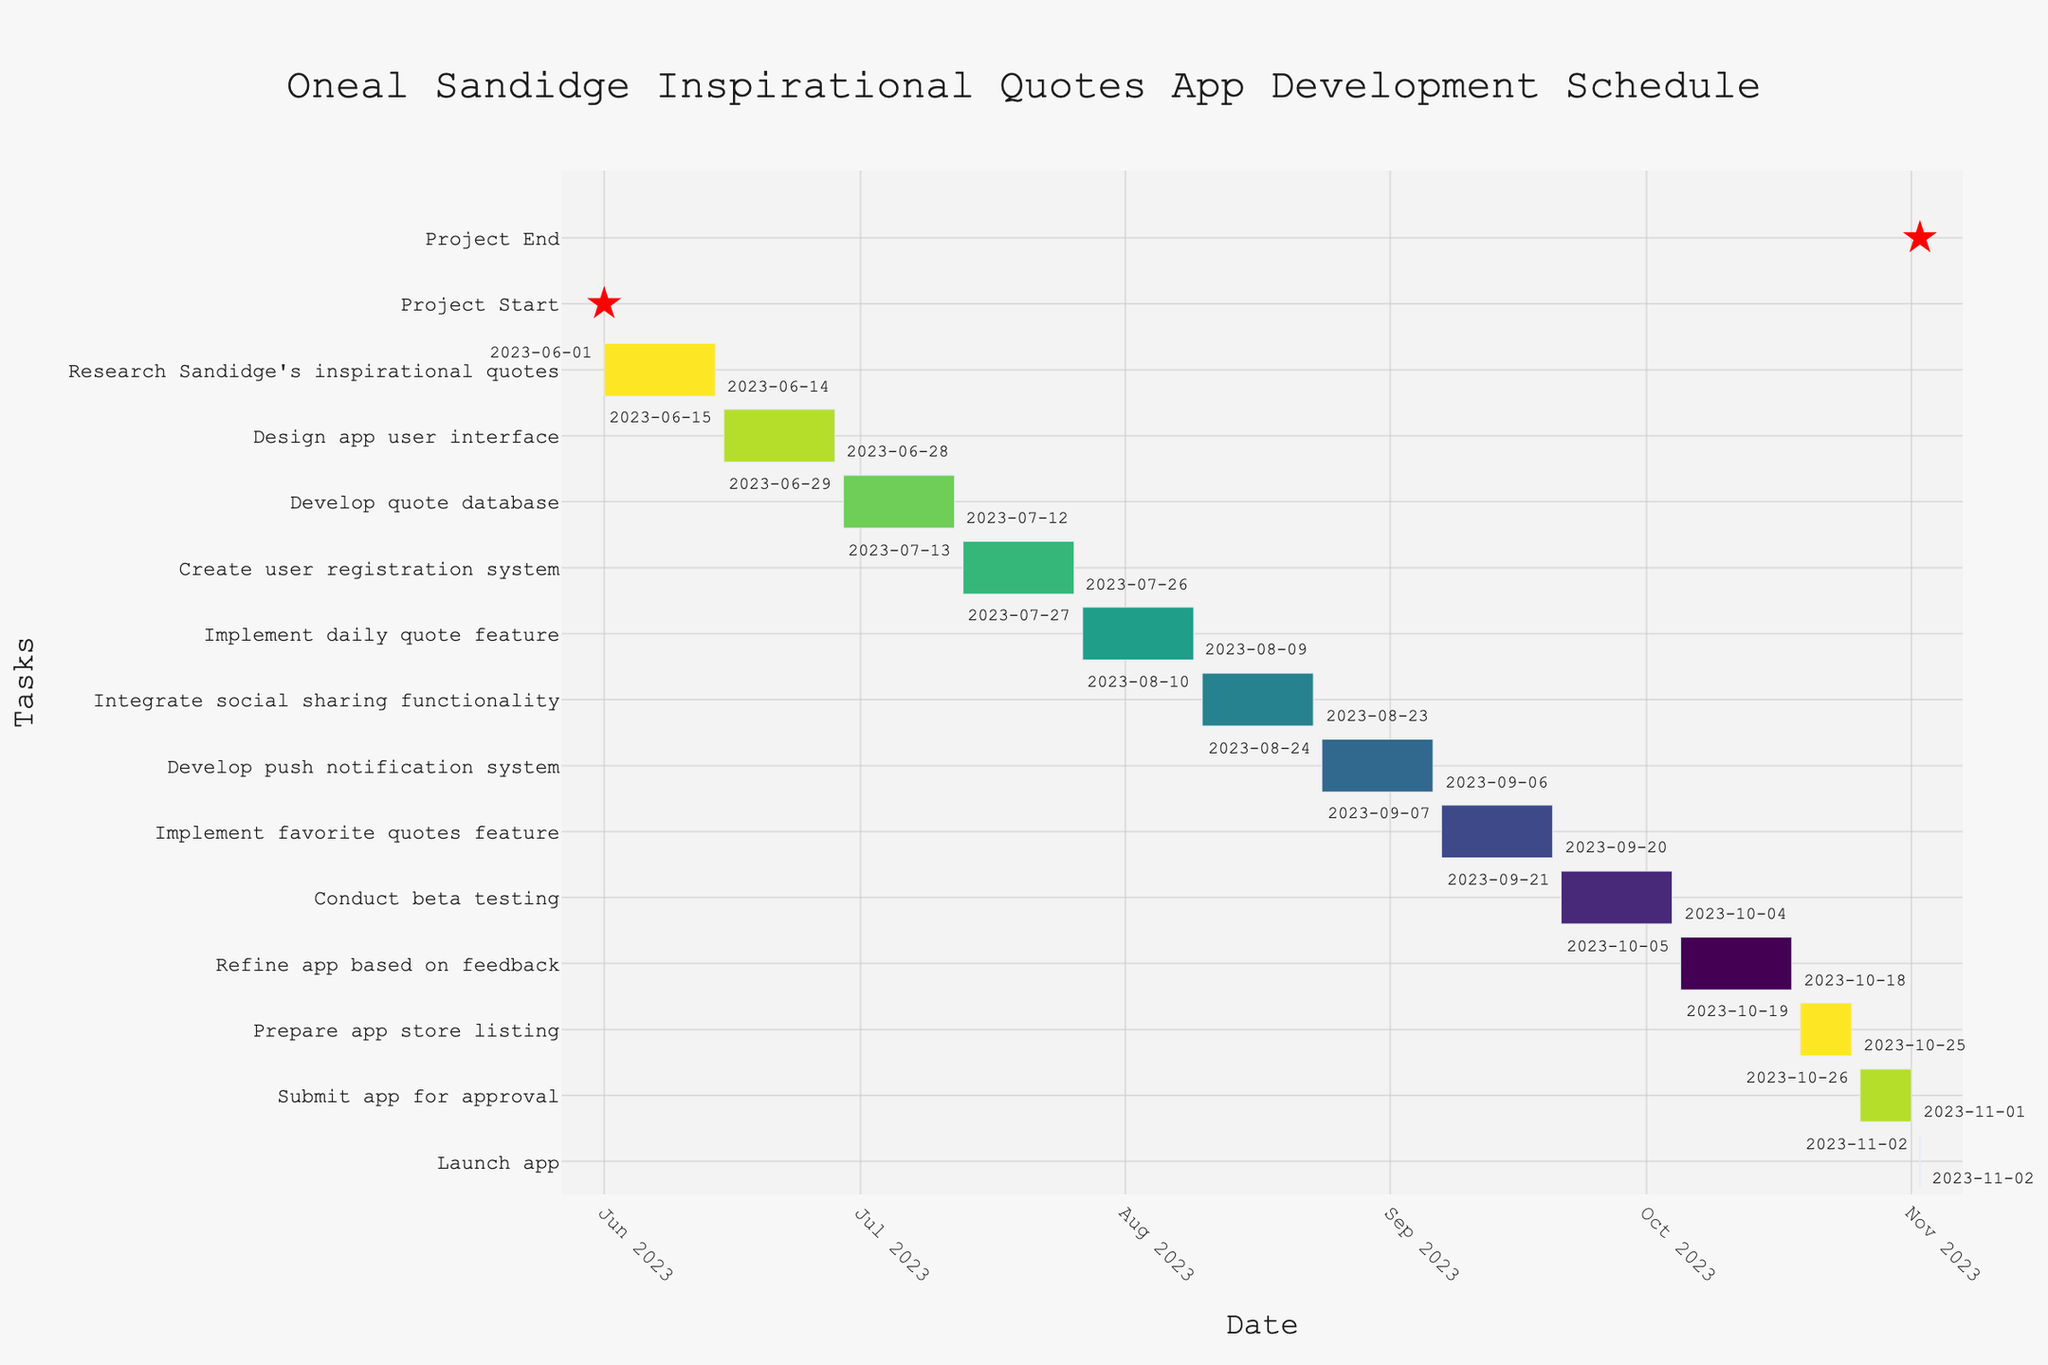Which task marks the beginning of the project? The project starts with the task listed at the top of the timeline. This initial task is "Research Sandidge's inspirational quotes," which begins on June 1, 2023.
Answer: Research Sandidge's inspirational quotes Which task marks the end of the project? The final task in the timeline is "Launch app," which takes place on November 2, 2023.
Answer: Launch app What is the total duration of the project from start to finish? To calculate the total duration, find the difference between the start date of the first task (June 1, 2023) and the end date of the last task (November 2, 2023). The total duration is 154 days.
Answer: 154 days How long is the duration for implementing the daily quote feature? The duration for implementing the daily quote feature is explicitly provided in the chart data and can be directly observed. This task takes 14 days (from July 27, 2023, to August 9, 2023).
Answer: 14 days Which tasks have a duration of exactly 7 days? The tasks that are notably shorter in duration are "Prepare app store listing" and "Submit app for approval," both lasting 7 days each.
Answer: Prepare app store listing and Submit app for approval Which task occurs immediately after developing the quote database? The task that follows "Develop quote database" (June 29, 2023 - July 12, 2023) starts on July 13, 2023. This task is "Create user registration system."
Answer: Create user registration system How many tasks are scheduled after implementing the daily quote feature? To count the number of tasks after the daily quote implementation, we start from "Integrate social sharing functionality" (August 10, 2023) and count until "Launch app" (November 2, 2023). There are 7 tasks.
Answer: 7 tasks Which task has the longest duration in the schedule? All tasks except two (each of 7 days) have the same standard duration of 14 days in the Gantt Chart. Thus, there is no single longest-duration task.
Answer: None, multiple tasks share the same longest duration What task is scheduled right before the app launch? Immediately before "Launch app" on November 2, 2023, the task is "Submit app for approval" which ends on November 1, 2023.
Answer: Submit app for approval 